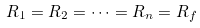Convert formula to latex. <formula><loc_0><loc_0><loc_500><loc_500>R _ { 1 } = R _ { 2 } = \cdots = R _ { n } = R _ { f }</formula> 